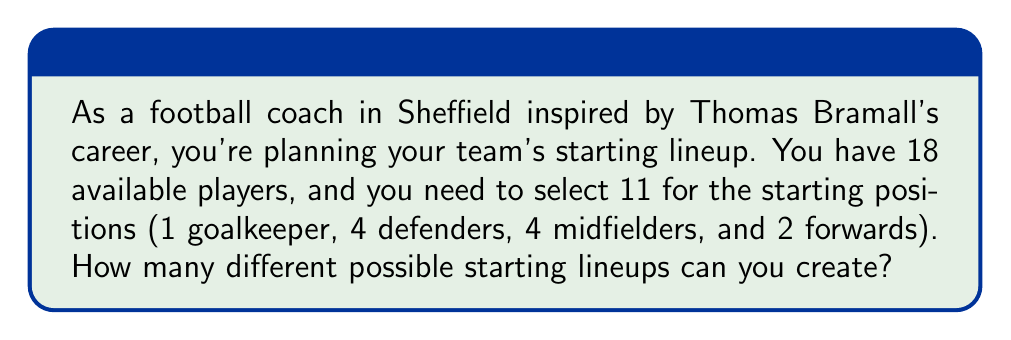Can you solve this math problem? To solve this problem, we'll use the combination formula and the multiplication principle of counting.

1. First, we need to select 1 goalkeeper from the 18 players:
   $${18 \choose 1} = 18$$

2. Then, we need to select 4 defenders from the remaining 17 players:
   $${17 \choose 4} = \frac{17!}{4!(17-4)!} = \frac{17!}{4!13!} = 2380$$

3. Next, we select 4 midfielders from the remaining 13 players:
   $${13 \choose 4} = \frac{13!}{4!(13-4)!} = \frac{13!}{4!9!} = 715$$

4. Finally, we select 2 forwards from the remaining 9 players:
   $${9 \choose 2} = \frac{9!}{2!(9-2)!} = \frac{9!}{2!7!} = 36$$

5. According to the multiplication principle, the total number of possible lineups is the product of these individual selections:

   $$18 \times 2380 \times 715 \times 36 = 1,225,566,400$$

Therefore, there are 1,225,566,400 different possible starting lineups.
Answer: 1,225,566,400 possible starting lineups 